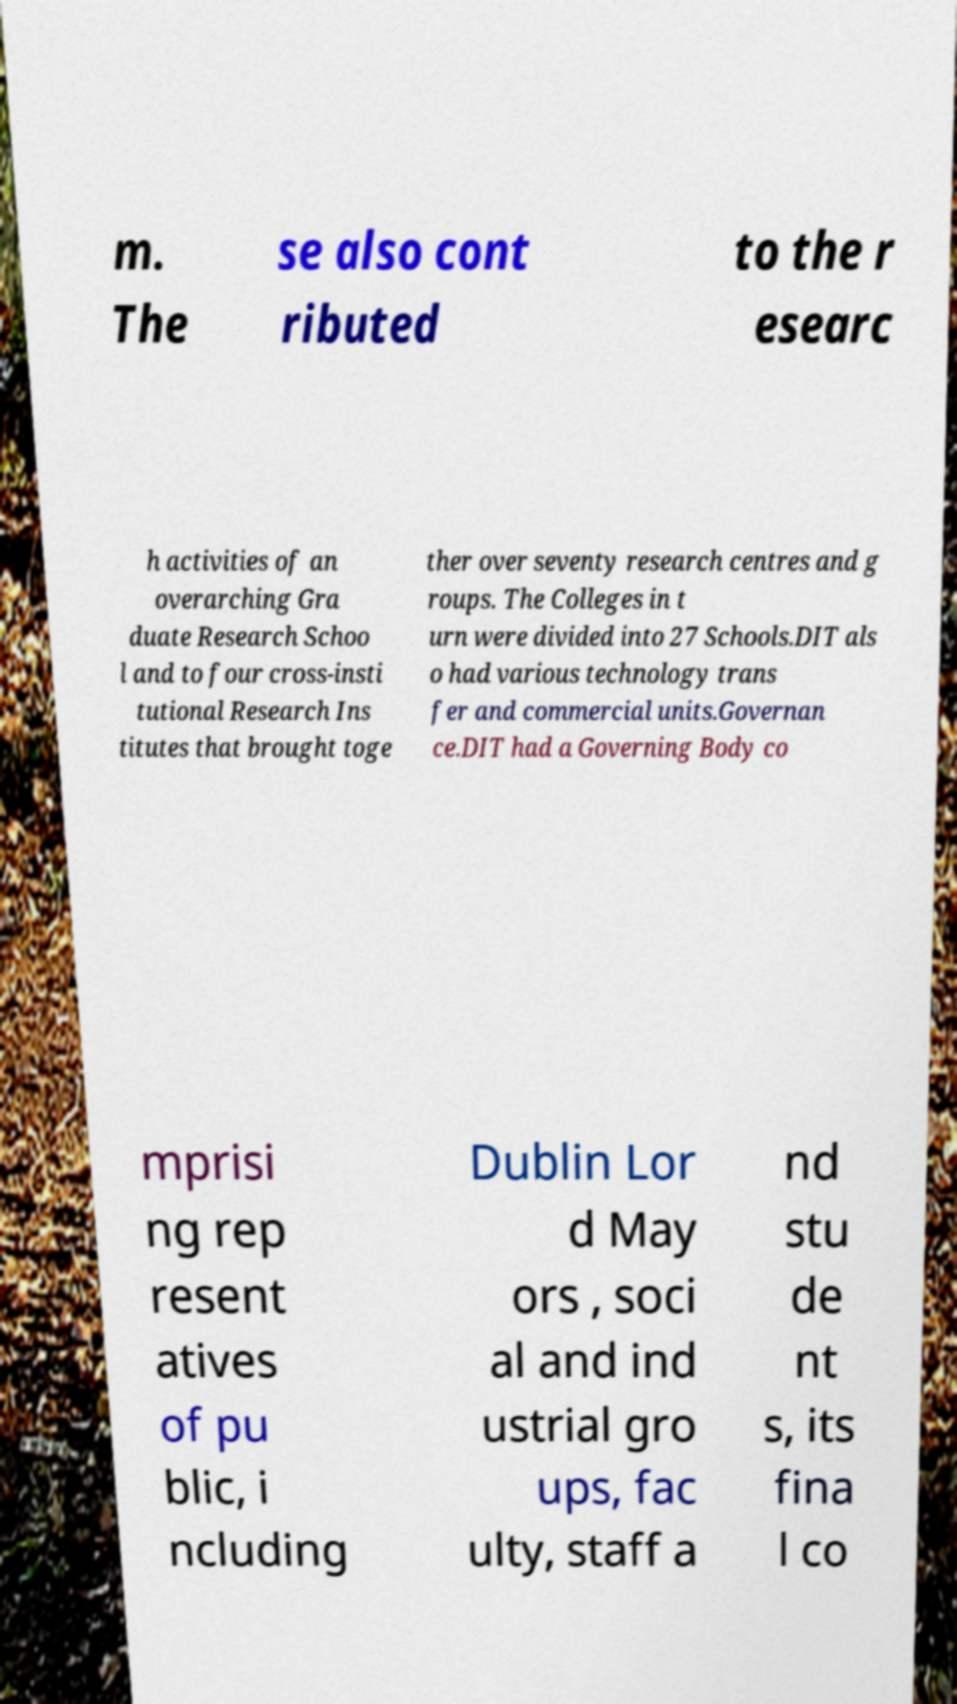I need the written content from this picture converted into text. Can you do that? m. The se also cont ributed to the r esearc h activities of an overarching Gra duate Research Schoo l and to four cross-insti tutional Research Ins titutes that brought toge ther over seventy research centres and g roups. The Colleges in t urn were divided into 27 Schools.DIT als o had various technology trans fer and commercial units.Governan ce.DIT had a Governing Body co mprisi ng rep resent atives of pu blic, i ncluding Dublin Lor d May ors , soci al and ind ustrial gro ups, fac ulty, staff a nd stu de nt s, its fina l co 